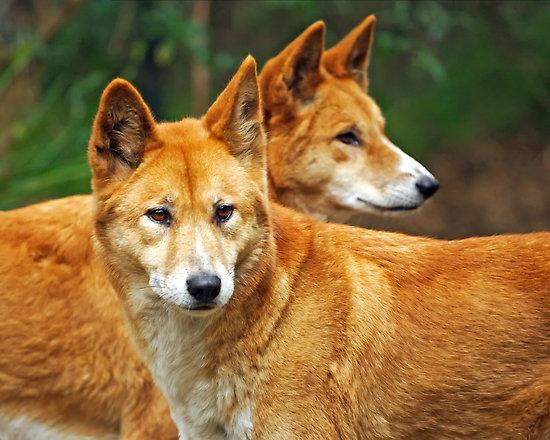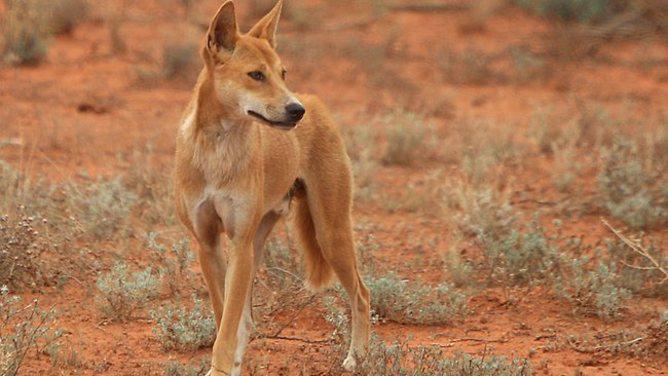The first image is the image on the left, the second image is the image on the right. Evaluate the accuracy of this statement regarding the images: "Each image shows only one wild dog, and the left image shows a dog with its body in profile turned rightward.". Is it true? Answer yes or no. No. The first image is the image on the left, the second image is the image on the right. For the images shown, is this caption "At least one image shows a single dog and no dog in any image has its mouth open." true? Answer yes or no. Yes. 